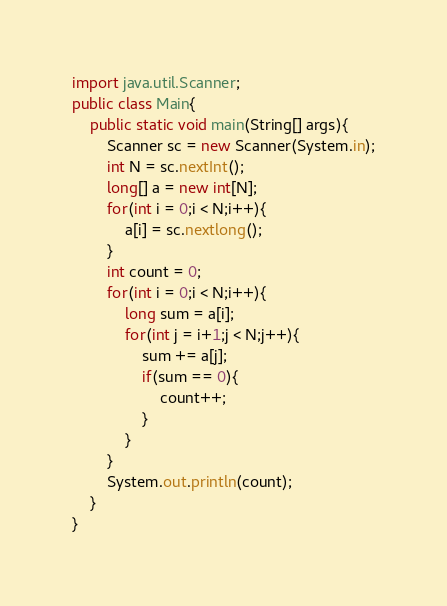<code> <loc_0><loc_0><loc_500><loc_500><_Java_>import java.util.Scanner;
public class Main{
    public static void main(String[] args){
        Scanner sc = new Scanner(System.in);
        int N = sc.nextInt();
        long[] a = new int[N];
        for(int i = 0;i < N;i++){
            a[i] = sc.nextlong();
        }
        int count = 0;
        for(int i = 0;i < N;i++){
            long sum = a[i];
            for(int j = i+1;j < N;j++){
                sum += a[j];
                if(sum == 0){
                    count++;
                }
            }
        }
        System.out.println(count);
    }
}
</code> 